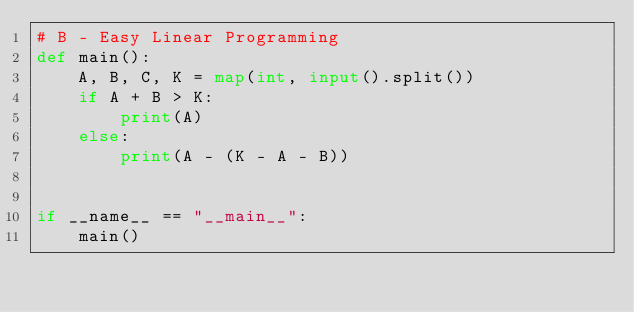Convert code to text. <code><loc_0><loc_0><loc_500><loc_500><_Python_># B - Easy Linear Programming
def main():
    A, B, C, K = map(int, input().split())
    if A + B > K:
        print(A)
    else:
        print(A - (K - A - B))


if __name__ == "__main__":
    main()
</code> 